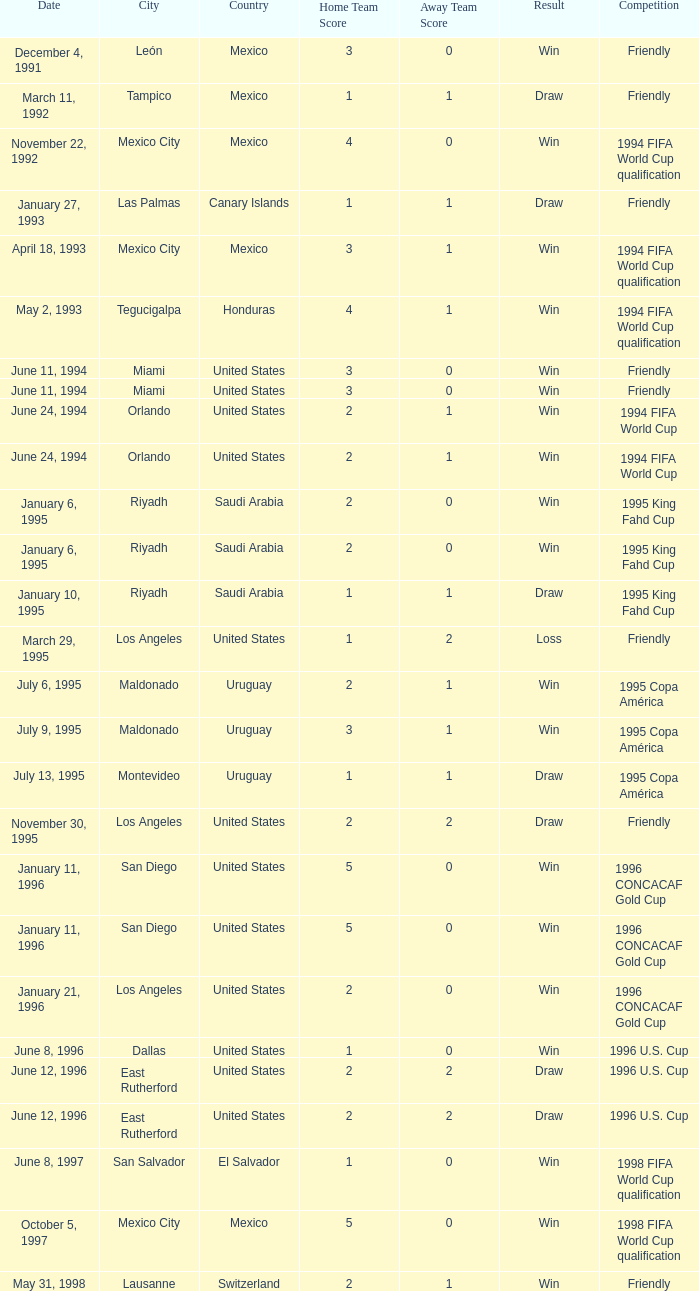What is Competition, when Date is "January 11, 1996", when Venue is "San Diego , United States"? 1996 CONCACAF Gold Cup, 1996 CONCACAF Gold Cup. 